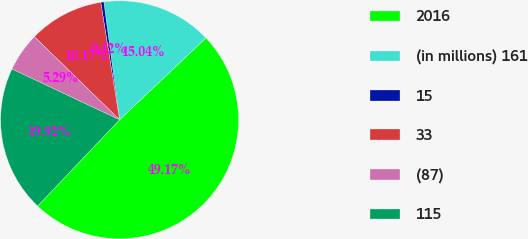<chart> <loc_0><loc_0><loc_500><loc_500><pie_chart><fcel>2016<fcel>(in millions) 161<fcel>15<fcel>33<fcel>(87)<fcel>115<nl><fcel>49.17%<fcel>15.04%<fcel>0.42%<fcel>10.17%<fcel>5.29%<fcel>19.92%<nl></chart> 